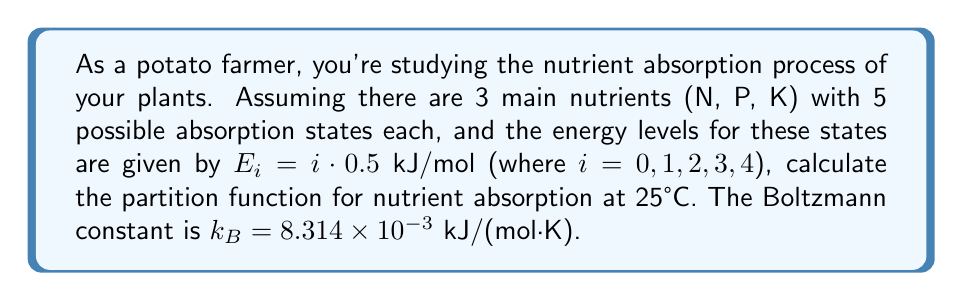Could you help me with this problem? Let's approach this step-by-step:

1) The partition function for a single nutrient with 5 states is given by:

   $$Z_1 = \sum_{i=0}^4 e^{-E_i/k_BT}$$

2) We need to calculate $k_BT$:
   $T = 25°C = 298.15K$
   $k_BT = 8.314 \times 10^{-3} \cdot 298.15 = 2.479$ kJ/mol

3) Now, let's calculate each term in the sum:

   For $i = 0$: $e^{-0/2.479} = 1$
   For $i = 1$: $e^{-0.5/2.479} = 0.8187$
   For $i = 2$: $e^{-1.0/2.479} = 0.6703$
   For $i = 3$: $e^{-1.5/2.479} = 0.5488$
   For $i = 4$: $e^{-2.0/2.479} = 0.4493$

4) Sum these up:
   $Z_1 = 1 + 0.8187 + 0.6703 + 0.5488 + 0.4493 = 3.4871$

5) Since there are 3 independent nutrients, and each has the same partition function, the total partition function is:

   $$Z_{total} = (Z_1)^3 = (3.4871)^3 = 42.3729$$
Answer: $42.3729$ 